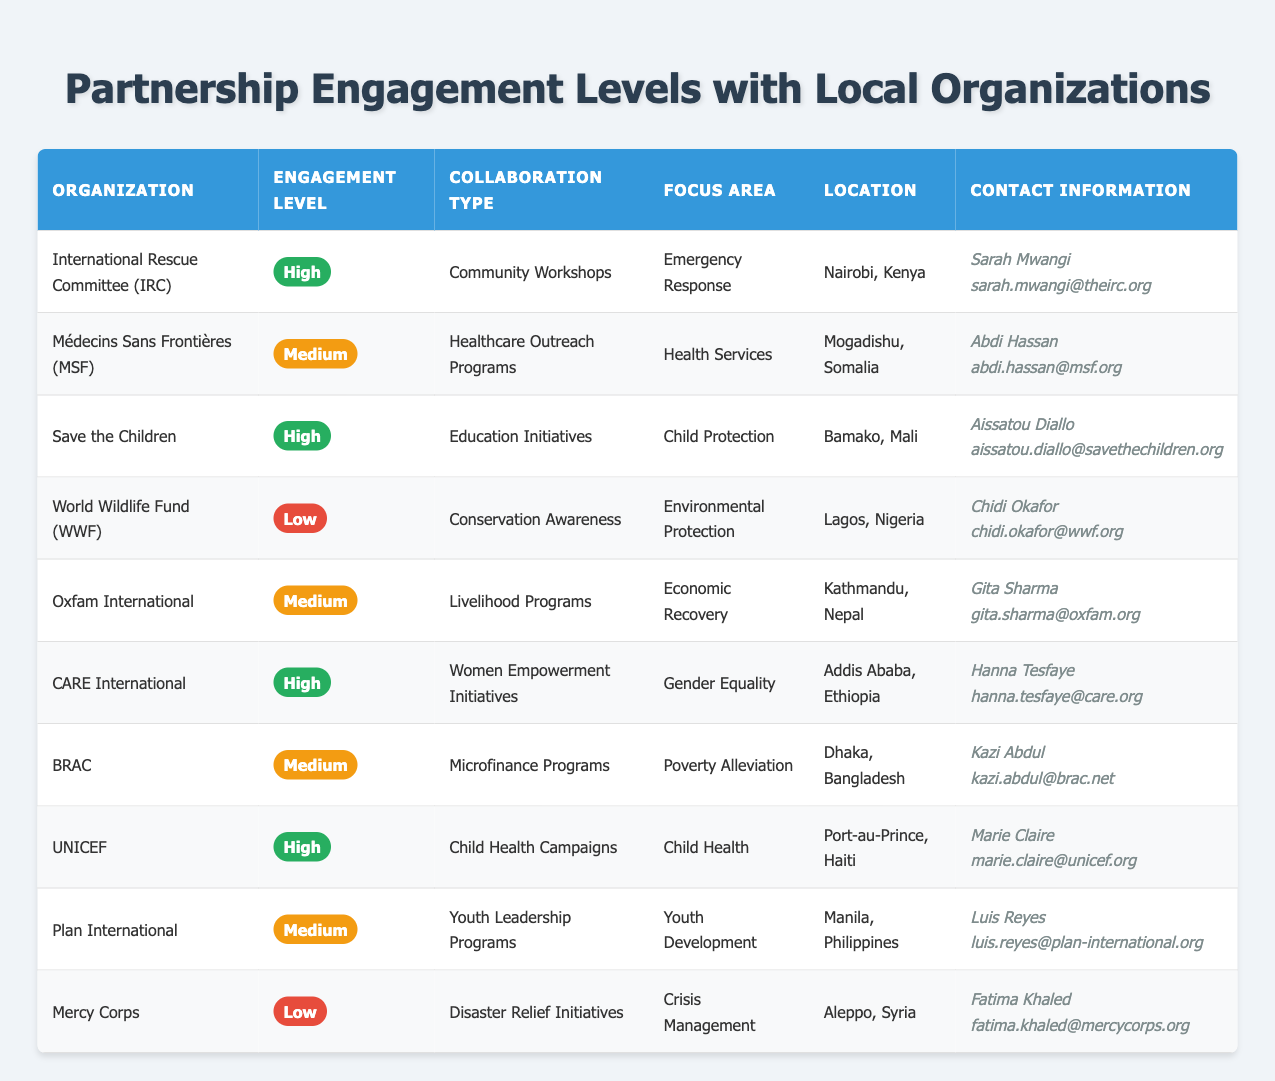What organizations have a high engagement level in Nairobi, Kenya? We look for organizations listed under the engagement level "High" specifically located in Nairobi, Kenya. The table shows that the International Rescue Committee (IRC) has a high engagement level and operates in Nairobi, Kenya.
Answer: International Rescue Committee (IRC) How many organizations have a medium engagement level? We can count the organizations under the engagement level "Medium". The table lists Médecins Sans Frontières (MSF), Oxfam International, BRAC, and Plan International, which totals four organizations.
Answer: 4 Is Save the Children involved in emergency response initiatives? To answer this, we check if Save the Children is associated with "Emergency Response" in the focus area. The table indicates that Save the Children is focused on "Child Protection," therefore they are not involved in emergency response initiatives.
Answer: No Which organization focuses on gender equality and what is their engagement level? We can look for the focus area "Gender Equality" in the table and identify the associated organization along with the engagement level. CARE International is noted for its focus on gender equality, and its engagement level is "High".
Answer: CARE International, High What is the collaboration type of the organization with the lowest engagement level? The organization with the lowest engagement level (Low) in the table is Mercy Corps, and the collaboration type mentioned is "Disaster Relief Initiatives".
Answer: Disaster Relief Initiatives How many organizations operate in Africa with a high engagement level? We need to identify organizations within the table located in African countries (Kenya, Somalia, Mali, Ethiopia, and Haiti) and that have a high engagement level. Checking, we find three organizations: IRC (Nairobi, Kenya), Save the Children (Bamako, Mali), and CARE International (Addis Ababa, Ethiopia), making a total of three organizations.
Answer: 3 Is UNICEF involved in healthcare outreach programs? We check the organization UNICEF and its listed collaboration type. The table states that UNICEF's collaboration type is "Child Health Campaigns," so they are not involved in healthcare outreach programs.
Answer: No What is the focus area for Oxfam International? We simply refer to the respective row for Oxfam International in the table. According to that row, the focus area for Oxfam International is "Economic Recovery".
Answer: Economic Recovery 